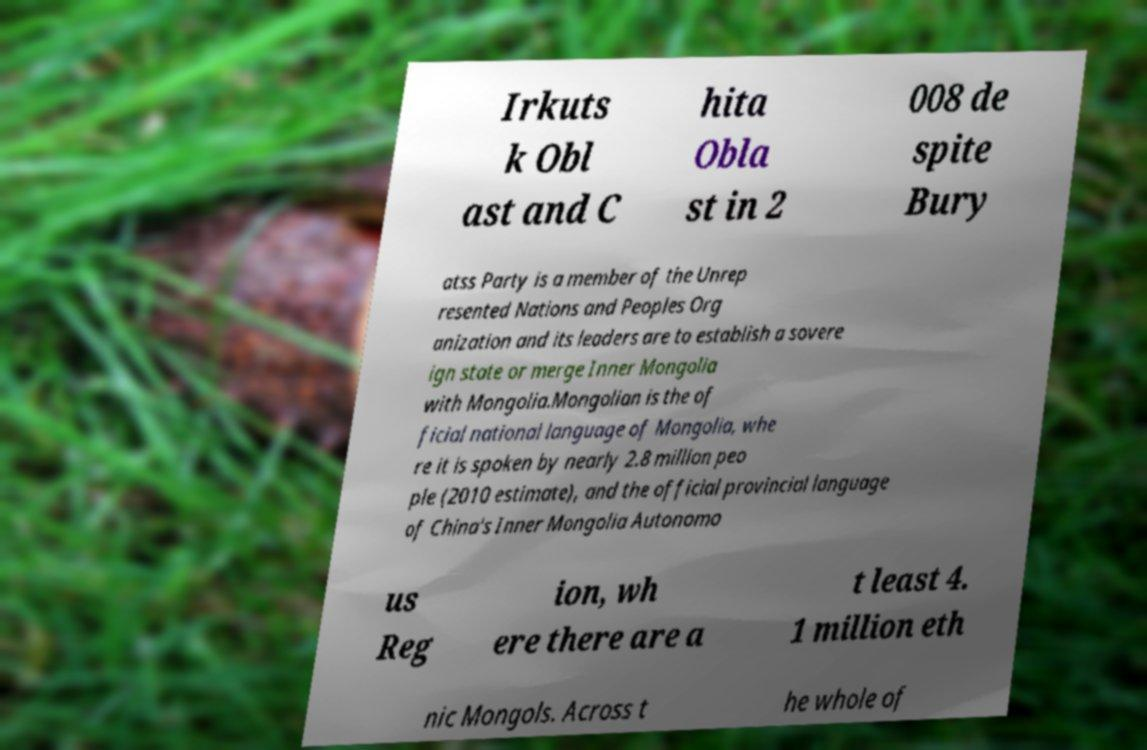Could you assist in decoding the text presented in this image and type it out clearly? Irkuts k Obl ast and C hita Obla st in 2 008 de spite Bury atss Party is a member of the Unrep resented Nations and Peoples Org anization and its leaders are to establish a sovere ign state or merge Inner Mongolia with Mongolia.Mongolian is the of ficial national language of Mongolia, whe re it is spoken by nearly 2.8 million peo ple (2010 estimate), and the official provincial language of China's Inner Mongolia Autonomo us Reg ion, wh ere there are a t least 4. 1 million eth nic Mongols. Across t he whole of 